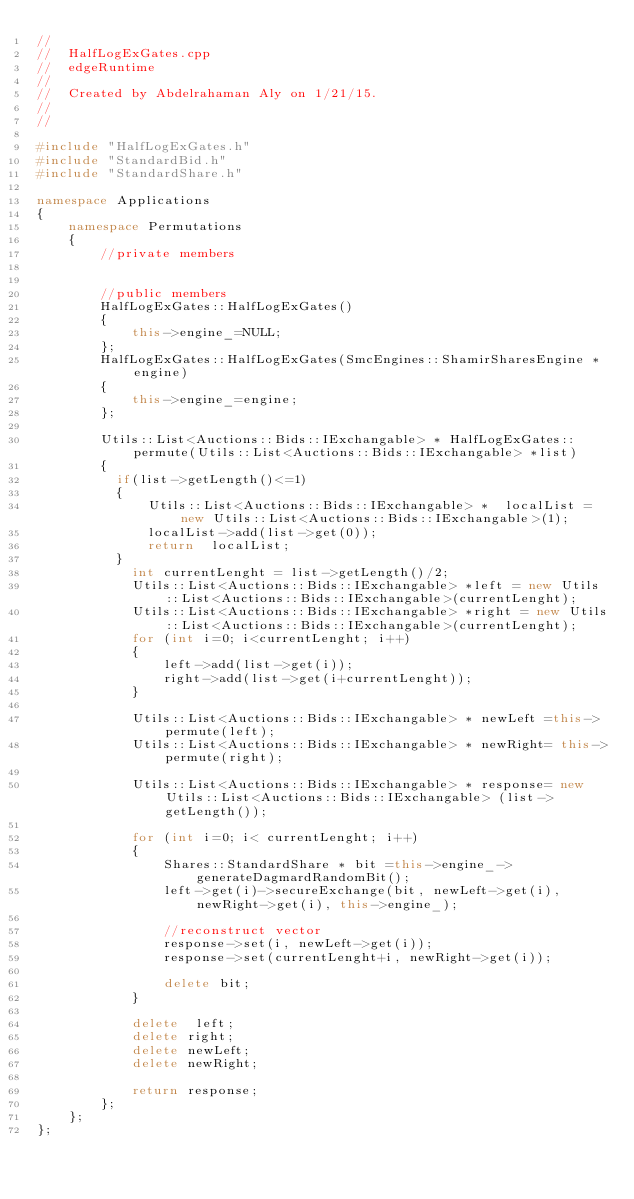Convert code to text. <code><loc_0><loc_0><loc_500><loc_500><_C++_>//
//  HalfLogExGates.cpp
//  edgeRuntime
//
//  Created by Abdelrahaman Aly on 1/21/15.
//
//

#include "HalfLogExGates.h"
#include "StandardBid.h"
#include "StandardShare.h"

namespace Applications
{
    namespace Permutations
    {
        //private members

        
        //public members
        HalfLogExGates::HalfLogExGates()
        {
            this->engine_=NULL;
        };
        HalfLogExGates::HalfLogExGates(SmcEngines::ShamirSharesEngine * engine)
        {
            this->engine_=engine;
        };
        
        Utils::List<Auctions::Bids::IExchangable> * HalfLogExGates::permute(Utils::List<Auctions::Bids::IExchangable> *list)
        {
          if(list->getLength()<=1)
          {
              Utils::List<Auctions::Bids::IExchangable> *  localList = new Utils::List<Auctions::Bids::IExchangable>(1);
              localList->add(list->get(0));
              return  localList;
          }
            int currentLenght = list->getLength()/2;
            Utils::List<Auctions::Bids::IExchangable> *left = new Utils::List<Auctions::Bids::IExchangable>(currentLenght);
            Utils::List<Auctions::Bids::IExchangable> *right = new Utils::List<Auctions::Bids::IExchangable>(currentLenght);
            for (int i=0; i<currentLenght; i++)
            {
                left->add(list->get(i));
                right->add(list->get(i+currentLenght));
            }
            
            Utils::List<Auctions::Bids::IExchangable> * newLeft =this->permute(left);
            Utils::List<Auctions::Bids::IExchangable> * newRight= this->permute(right);
            
            Utils::List<Auctions::Bids::IExchangable> * response= new  Utils::List<Auctions::Bids::IExchangable> (list->getLength());
            
            for (int i=0; i< currentLenght; i++)
            {
                Shares::StandardShare * bit =this->engine_->generateDagmardRandomBit();
                left->get(i)->secureExchange(bit, newLeft->get(i), newRight->get(i), this->engine_);
                
                //reconstruct vector
                response->set(i, newLeft->get(i));
                response->set(currentLenght+i, newRight->get(i));
                
                delete bit; 
            }
            
            delete  left;
            delete right;
            delete newLeft;
            delete newRight;
           
            return response;
        };
    };
};</code> 